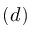<formula> <loc_0><loc_0><loc_500><loc_500>( d )</formula> 